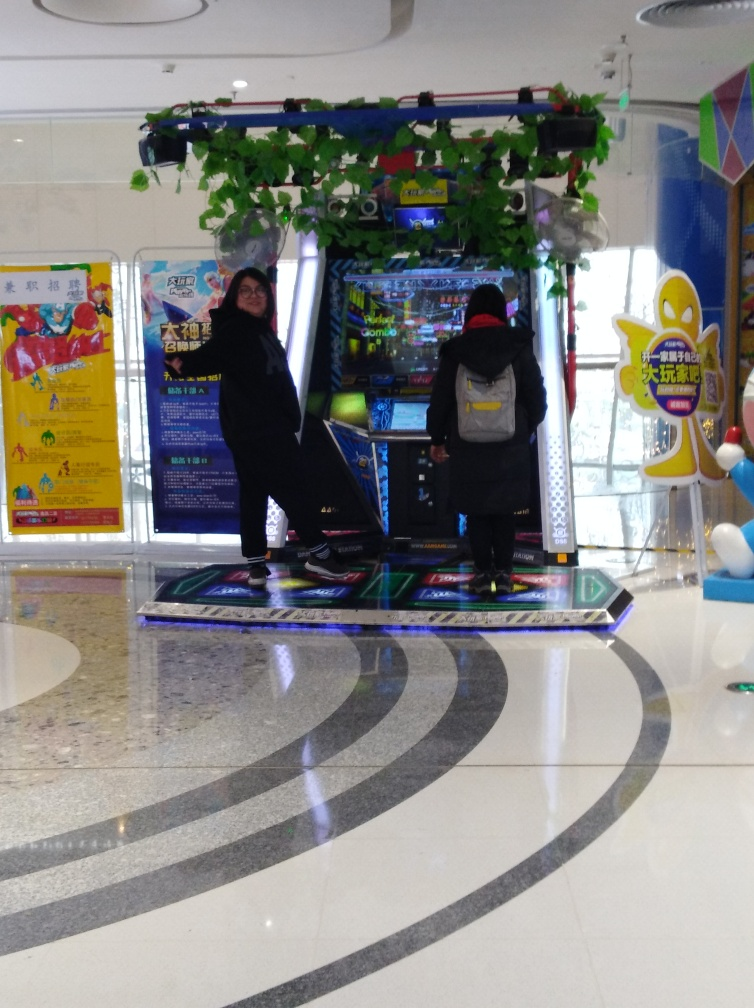What are the people in the image doing? The individuals appear to be engaged in playing an arcade dance game, standing on platforms with directional arrows and following the visual cues on the screen in front of them. 